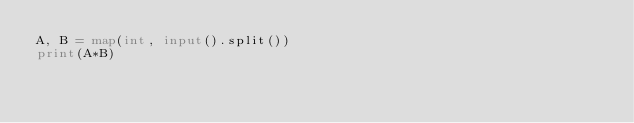Convert code to text. <code><loc_0><loc_0><loc_500><loc_500><_Python_>A, B = map(int, input().split())
print(A*B)</code> 